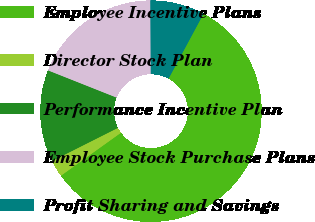Convert chart to OTSL. <chart><loc_0><loc_0><loc_500><loc_500><pie_chart><fcel>Employee Incentive Plans<fcel>Director Stock Plan<fcel>Performance Incentive Plan<fcel>Employee Stock Purchase Plans<fcel>Profit Sharing and Savings<nl><fcel>57.24%<fcel>2.47%<fcel>13.43%<fcel>18.9%<fcel>7.95%<nl></chart> 